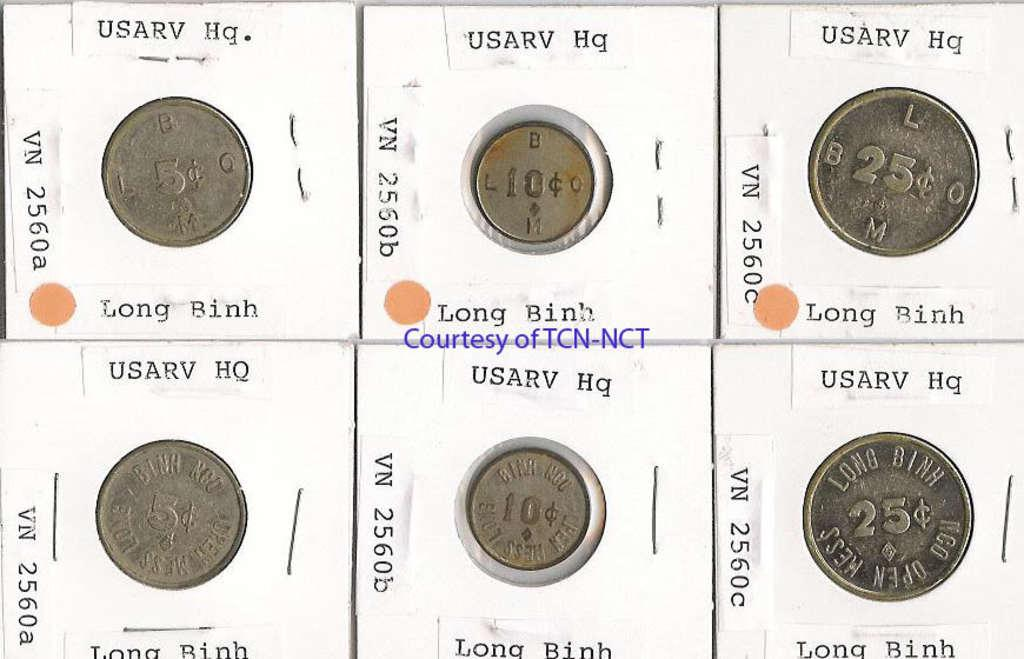<image>
Create a compact narrative representing the image presented. Different coins that all have the same wording on top, which is USARV Hq. and VN 2560a. 